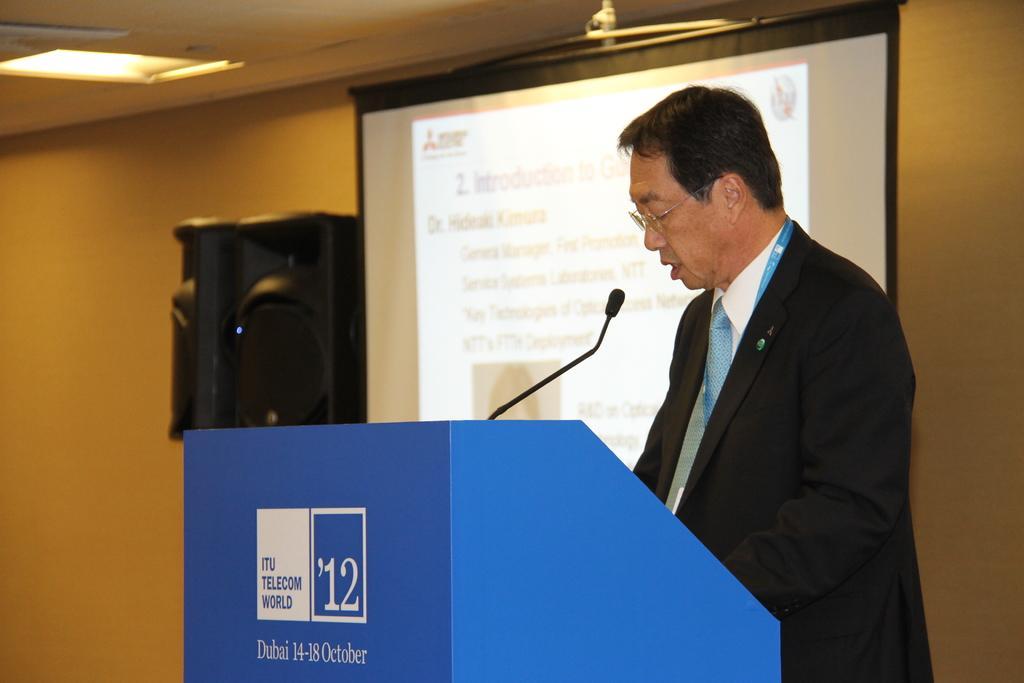Can you describe this image briefly? In the foreground of this image, there is a man standing in front of a podium on which there is a mic. In the background, there is a screen and speaker boxes on the wall. At the top, there is a light to the ceiling. 